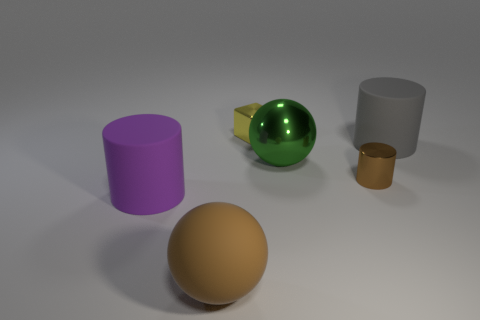Add 2 tiny purple cubes. How many objects exist? 8 Subtract all blocks. How many objects are left? 5 Subtract 0 blue blocks. How many objects are left? 6 Subtract all small cyan cubes. Subtract all green balls. How many objects are left? 5 Add 6 big purple matte cylinders. How many big purple matte cylinders are left? 7 Add 3 gray things. How many gray things exist? 4 